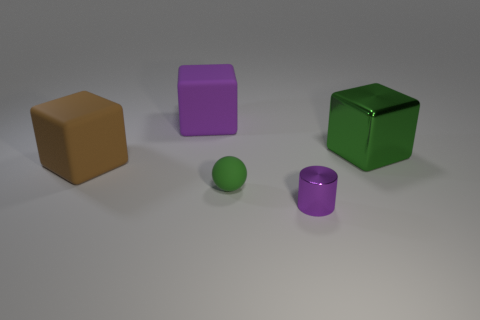Can you describe the different colors and shapes present in the image? Certainly! In the image, you can observe five objects with a variety of colors and shapes. There's a brown cube, a purple cube, a green cube, a small purple cylinder, and a small green sphere. Each object is distinct both in its geometric form and its hue. 